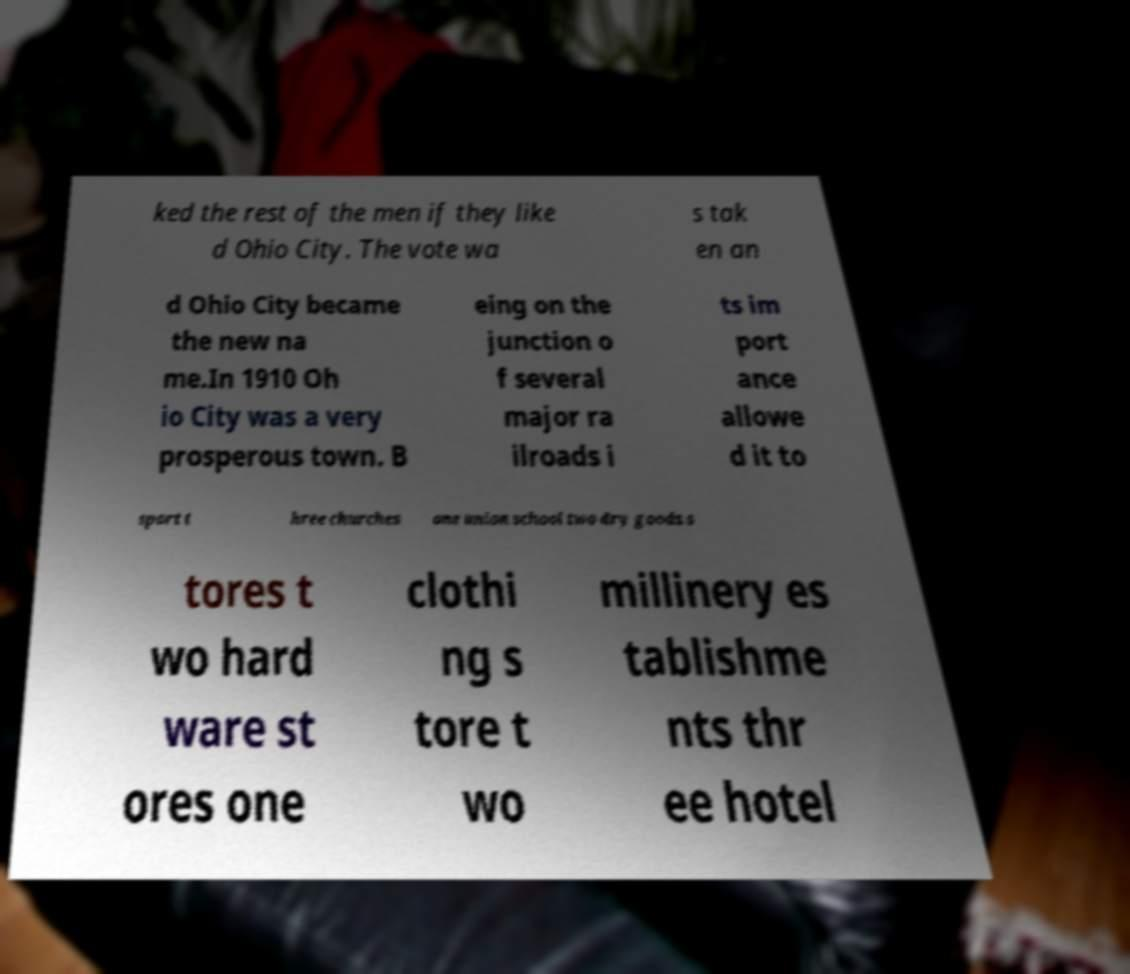Could you assist in decoding the text presented in this image and type it out clearly? ked the rest of the men if they like d Ohio City. The vote wa s tak en an d Ohio City became the new na me.In 1910 Oh io City was a very prosperous town. B eing on the junction o f several major ra ilroads i ts im port ance allowe d it to sport t hree churches one union school two dry goods s tores t wo hard ware st ores one clothi ng s tore t wo millinery es tablishme nts thr ee hotel 